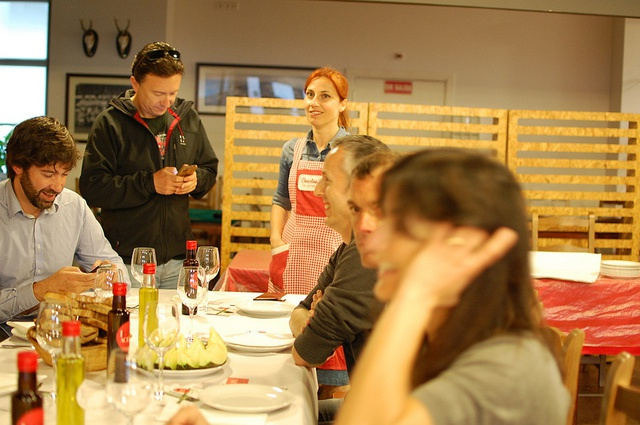Describe the objects in this image and their specific colors. I can see people in gray, maroon, orange, and tan tones, dining table in gray, khaki, beige, tan, and orange tones, people in gray, black, maroon, olive, and brown tones, people in gray, tan, and black tones, and people in gray, maroon, black, and orange tones in this image. 